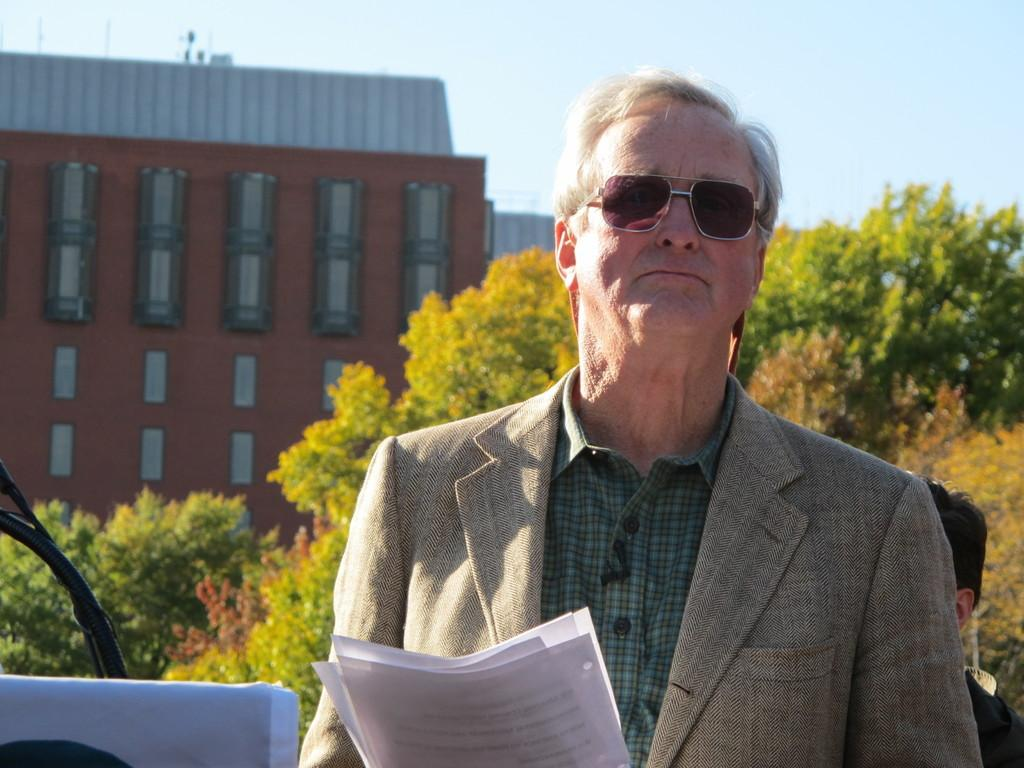What is the person in the image holding? The person is holding some papers in the image. What can be seen in the background of the image? There is a group of trees and a building with windows visible in the background. How would you describe the sky in the image? The sky is visible in the background and appears cloudy. What is the price of the train in the image? There is no train present in the image, so it is not possible to determine its price. 